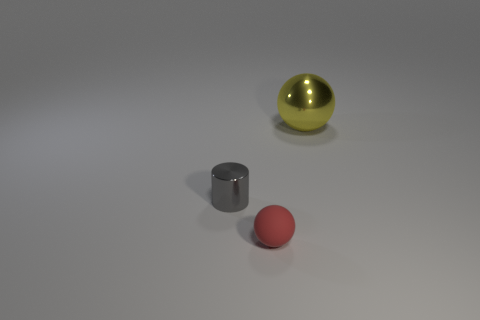Is there any other thing that has the same size as the metal sphere?
Make the answer very short. No. Is there anything else that is made of the same material as the tiny red ball?
Provide a short and direct response. No. Do the rubber thing and the cylinder have the same size?
Your response must be concise. Yes. There is a metallic thing to the left of the sphere behind the tiny matte thing; is there a tiny red object on the right side of it?
Offer a very short reply. Yes. The yellow metal ball has what size?
Make the answer very short. Large. What number of red objects are the same size as the matte ball?
Keep it short and to the point. 0. What material is the red object that is the same shape as the yellow object?
Your answer should be very brief. Rubber. The object that is on the right side of the tiny gray metallic cylinder and behind the rubber ball has what shape?
Keep it short and to the point. Sphere. The small object that is on the right side of the metal cylinder has what shape?
Your response must be concise. Sphere. How many objects are on the left side of the large yellow object and to the right of the red matte sphere?
Provide a short and direct response. 0. 